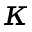<formula> <loc_0><loc_0><loc_500><loc_500>\kappa</formula> 